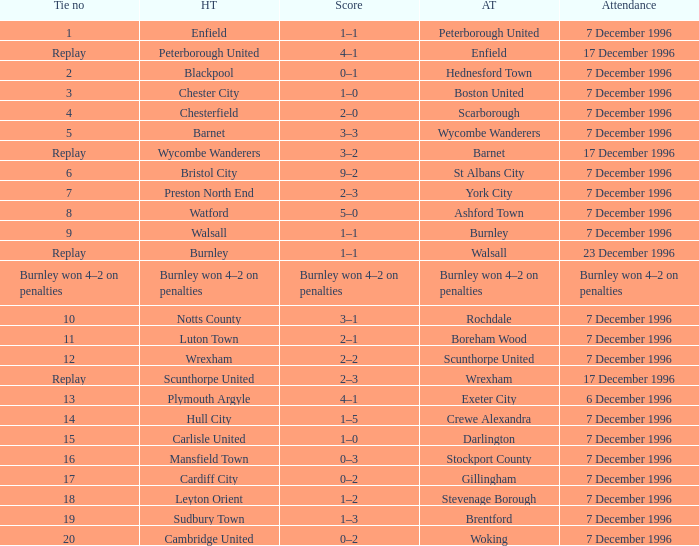What was the attendance for the home team of Walsall? 7 December 1996. 